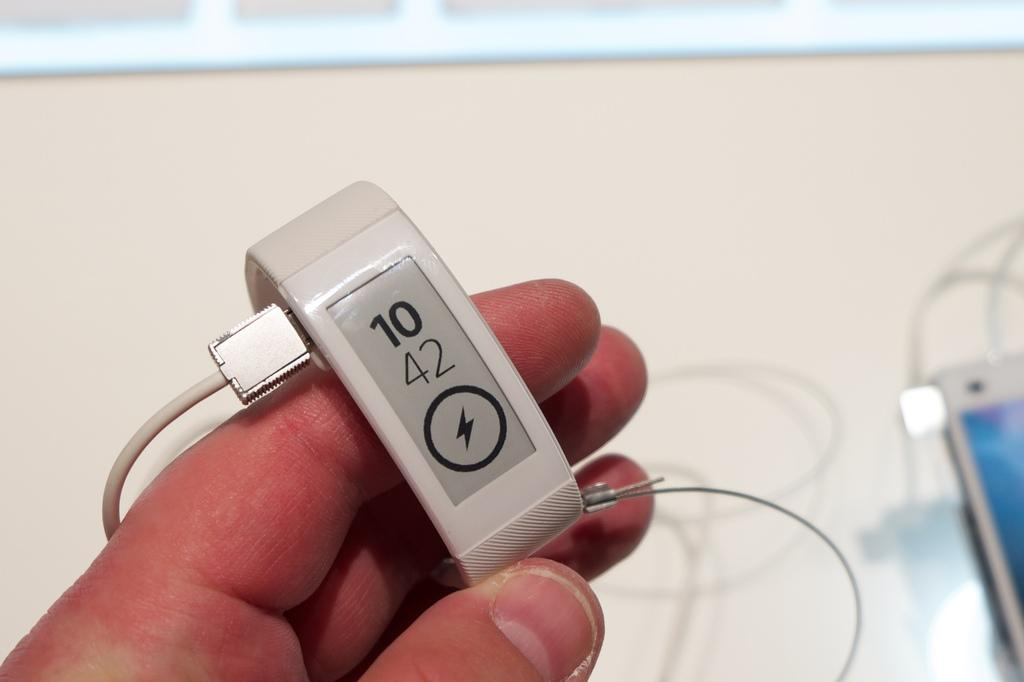<image>
Summarize the visual content of the image. Appears to be a smart watch with the numbers 10 and 42 and a lightning bolt on the screen. 